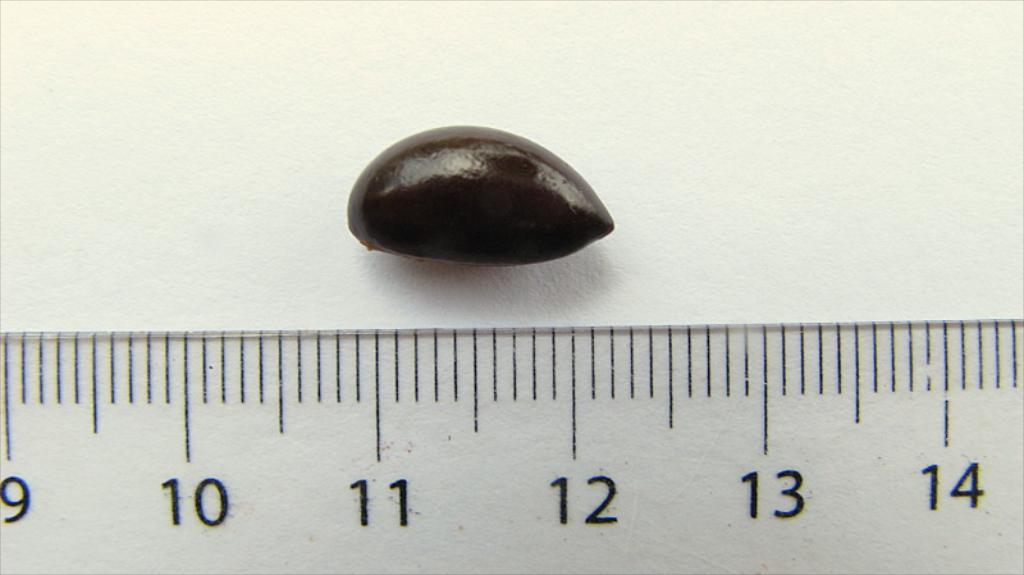How many numbers are on the ruler?
Your answer should be very brief. 6. 